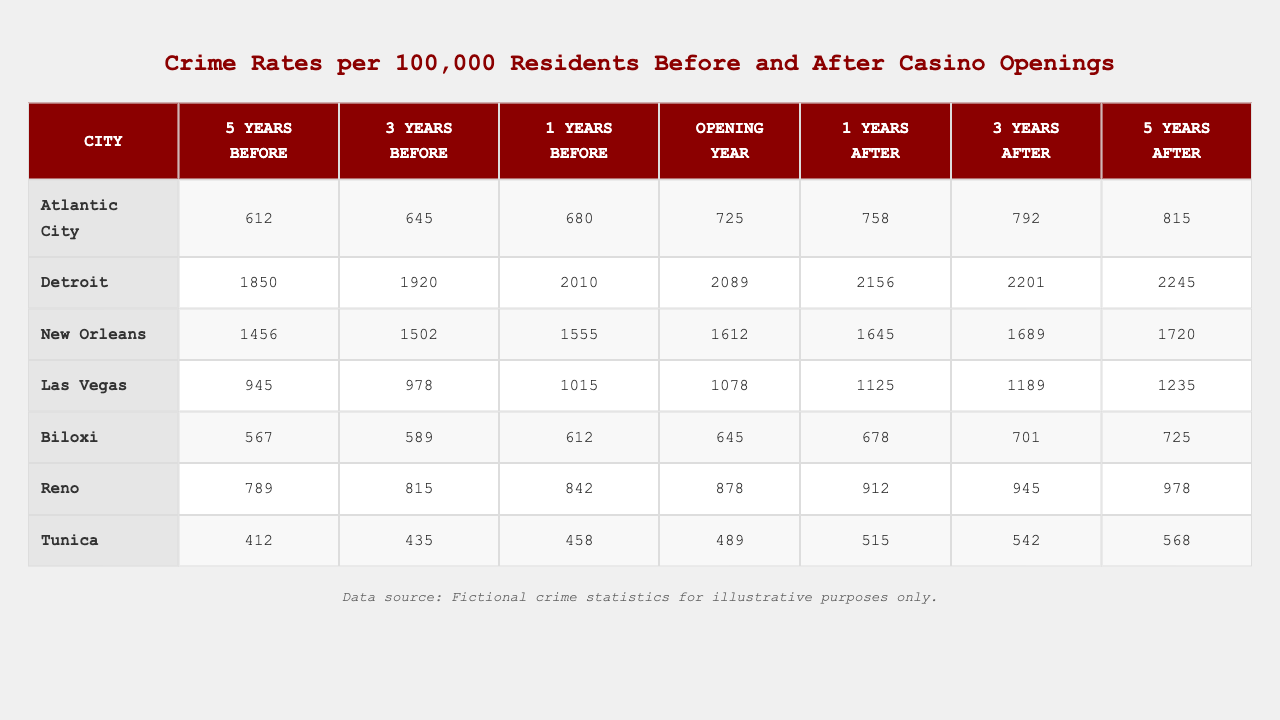What was the crime rate in Atlantic City five years after the casino opening? The crime rate in Atlantic City five years after the casino opening is located in the last column for that city, which is 815 per 100,000 residents.
Answer: 815 Which city had the highest crime rate three years before the casino opening? In the table, the crime rates three years before the casino opening for each city are listed. Detroit shows the highest rate at 1920 per 100,000 residents.
Answer: Detroit What is the crime rate change from one year before to one year after the casino opened in Las Vegas? To find the change, subtract the crime rate one year before (1015) from the one year after (1125). The calculation is 1125 - 1015 = 110.
Answer: 110 Did the crime rate in Biloxi decrease from three years to one year after the casino opening? Checking the table for Biloxi's crime rates, three years after is 701 and one year after is 678. Since 678 is less than 701, the crime rate did decrease.
Answer: Yes Which city experienced the smallest increase in crime rate from five years before to five years after the casino opening? First, find the crime rates for each city five years before and after opening. For the cities: Atlantic City increased from 612 to 815 (203), Detroit from 1850 to 2245 (395), New Orleans from 1456 to 1720 (264), Las Vegas from 945 to 1235 (290), Biloxi from 567 to 725 (158), Reno from 789 to 978 (189), and Tunica from 412 to 568 (156). Biloxi had the smallest increase of 158.
Answer: Biloxi What was the average crime rate in the year before the casino opened across all cities? The year before the casino opening corresponds to the column labeled -1. Add the crime rates for that year: (680 + 2010 + 1555 + 1015 + 612 + 842 + 458 = 5842). Then divide by the number of cities (7): 5842/7 = 834.57.
Answer: 834.57 Is it true that crime rates increased in every city in the year after the casino opened compared to the opening year? By comparing the crime rates, Atlantic City increased from 725 to 758, Detroit from 2089 to 2156, New Orleans from 1612 to 1645, Las Vegas from 1078 to 1125, Biloxi from 645 to 678, Reno from 878 to 912, and Tunica from 489 to 515. All cities show an increase; therefore, the statement is true.
Answer: Yes What was the difference in crime rates between the opening year and five years after in Tunica? Looking at Tunica's opening year crime rate of 489 and five years after at 568, the difference is 568 - 489 = 79.
Answer: 79 Which city's crime rate was closest to 1000 in the year after the casino opened? In the year after the casino opening, Las Vegas reported a crime rate of 1125, which is the closest to 1000; no other city has a crime rate near that number in the corresponding column.
Answer: Las Vegas How much did the crime rate in Reno increase from the year before the casino opened to the year after? To calculate the increase, take Reno's crime rate one year before, which is 842, and one year after, which is 912. The difference is: 912 - 842 = 70.
Answer: 70 